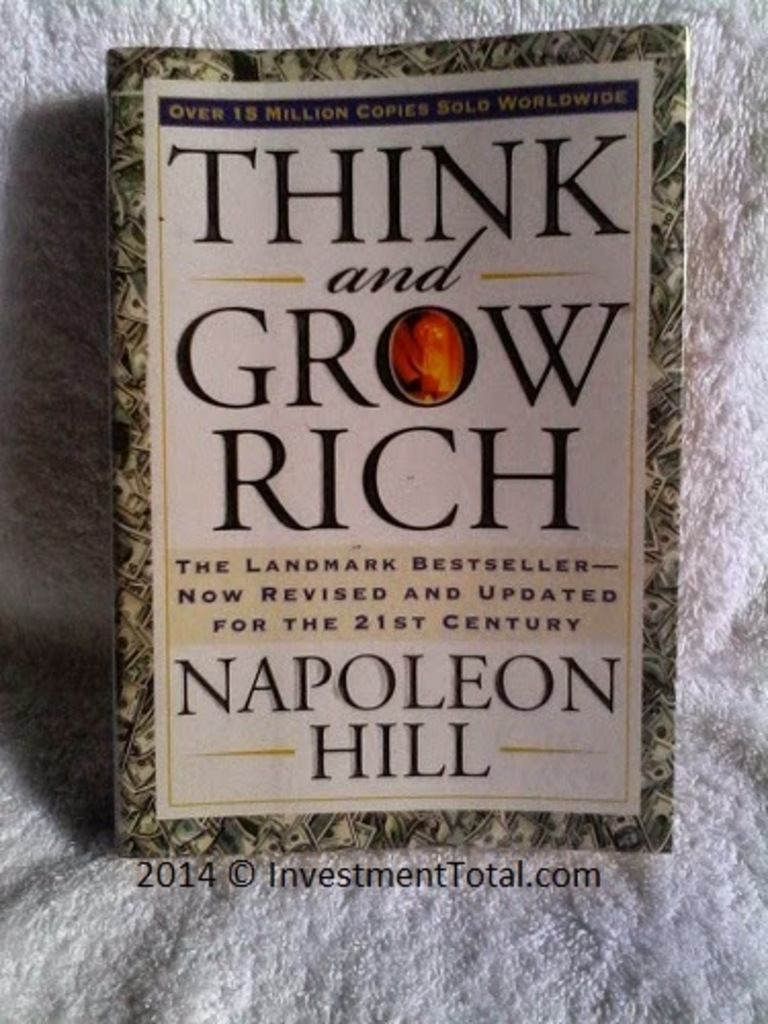Can you describe the main features of this image for me? The image features the book cover of 'Think and Grow Rich' by Napoleon Hill, showcased in a vertical orientation. The cover embodies a sophisticated design with a color palette primarily of dark green and gold accents. The title of the book is emblazoned across the top in large, ornate gold lettering that captures immediate attention, while the author's name is positioned below in smaller, yet prominent gold text. The centerpiece of the design is a striking red and gold emblem highlighting the word 'Rich', which adds a luxurious touch. This particular edition is noted as a landmark bestseller, now revised and updated for the 21st century, with a claim of over 15 million copies sold worldwide, emphasizing its enduring popularity and influence. 